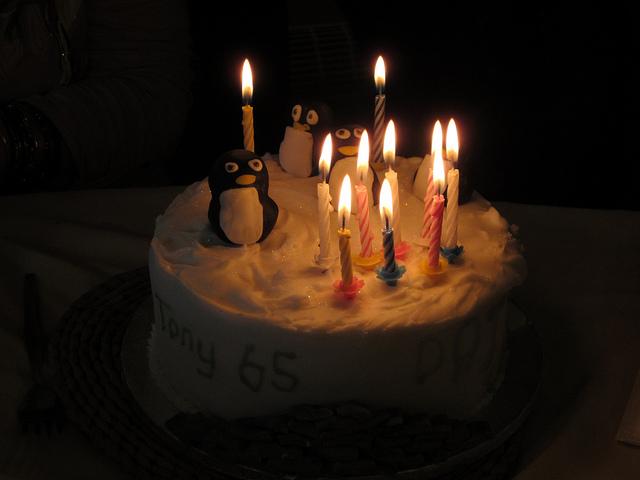What is the name on the side of the cake?
Short answer required. Tony. How many candles are on the cake?
Concise answer only. 10. Is this cake professionally made?
Give a very brief answer. No. What sort of animals are on the cake?
Short answer required. Penguins. What are the four colors of the candles?
Quick response, please. Pink,blue,yellow,white. Does this cake contain high levels of sugar?
Answer briefly. Yes. How many colors of candles are there?
Short answer required. 4. How many candles are in this picture?
Give a very brief answer. 10. 